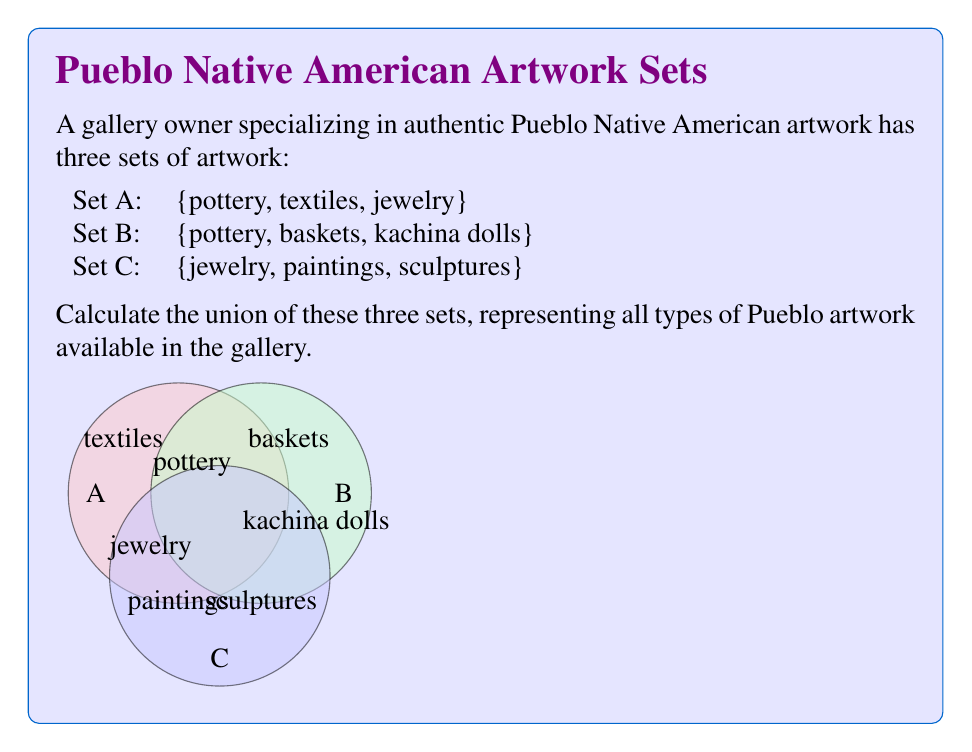Can you solve this math problem? To calculate the union of sets A, B, and C, we need to combine all unique elements from all three sets. Let's follow these steps:

1) First, list all elements from set A:
   $A = \{pottery, textiles, jewelry\}$

2) Add any new elements from set B that are not already included:
   $A \cup B = \{pottery, textiles, jewelry, baskets, kachina dolls\}$

3) Finally, add any new elements from set C that are not already included:
   $A \cup B \cup C = \{pottery, textiles, jewelry, baskets, kachina dolls, paintings, sculptures\}$

4) Count the total number of unique elements in the union:
   $|A \cup B \cup C| = 7$

The union of these three sets contains all unique types of Pueblo artwork available in the gallery, without any repetitions.
Answer: $A \cup B \cup C = \{pottery, textiles, jewelry, baskets, kachina dolls, paintings, sculptures\}$ 